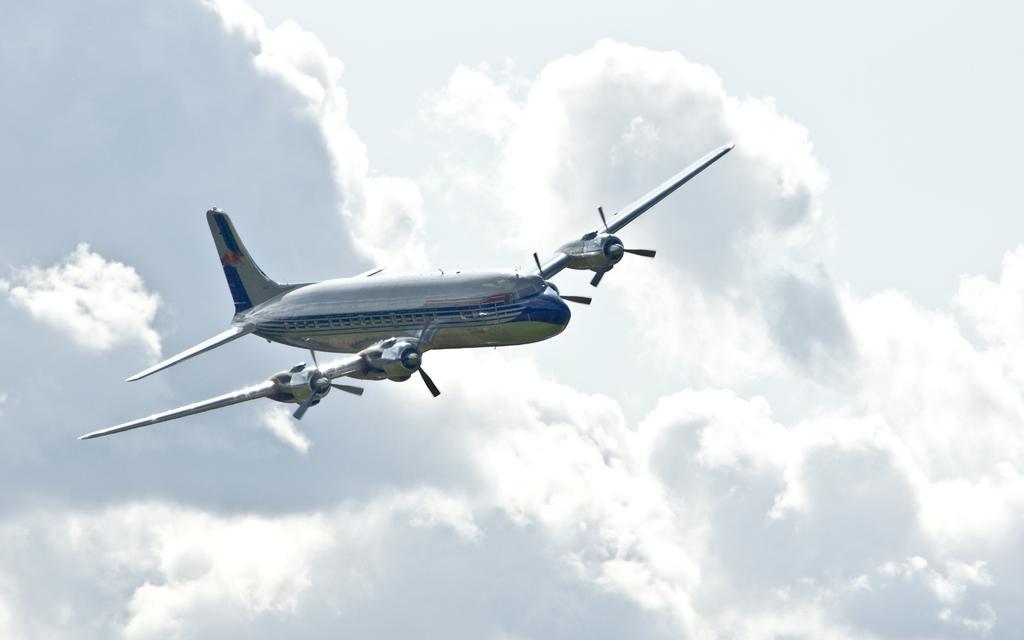Could you give a brief overview of what you see in this image? There is an aeroplane in the air, and there is a cloudy sky in the background. 